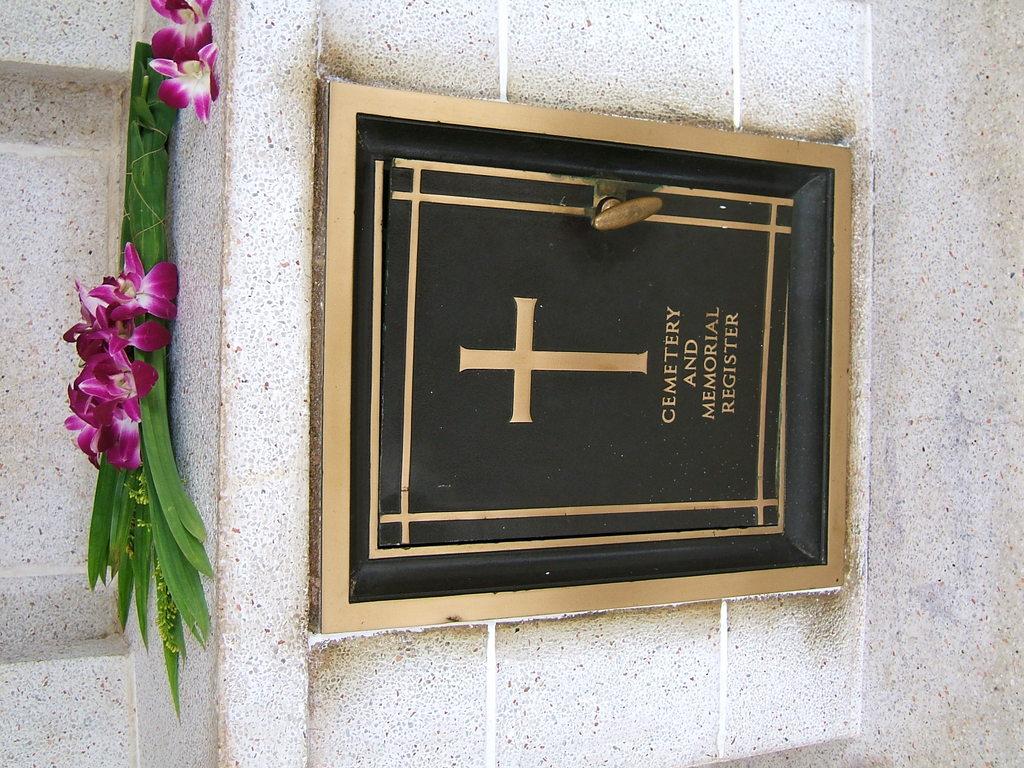What is written on the plaque?
Your response must be concise. Cemetery and memorial register. 